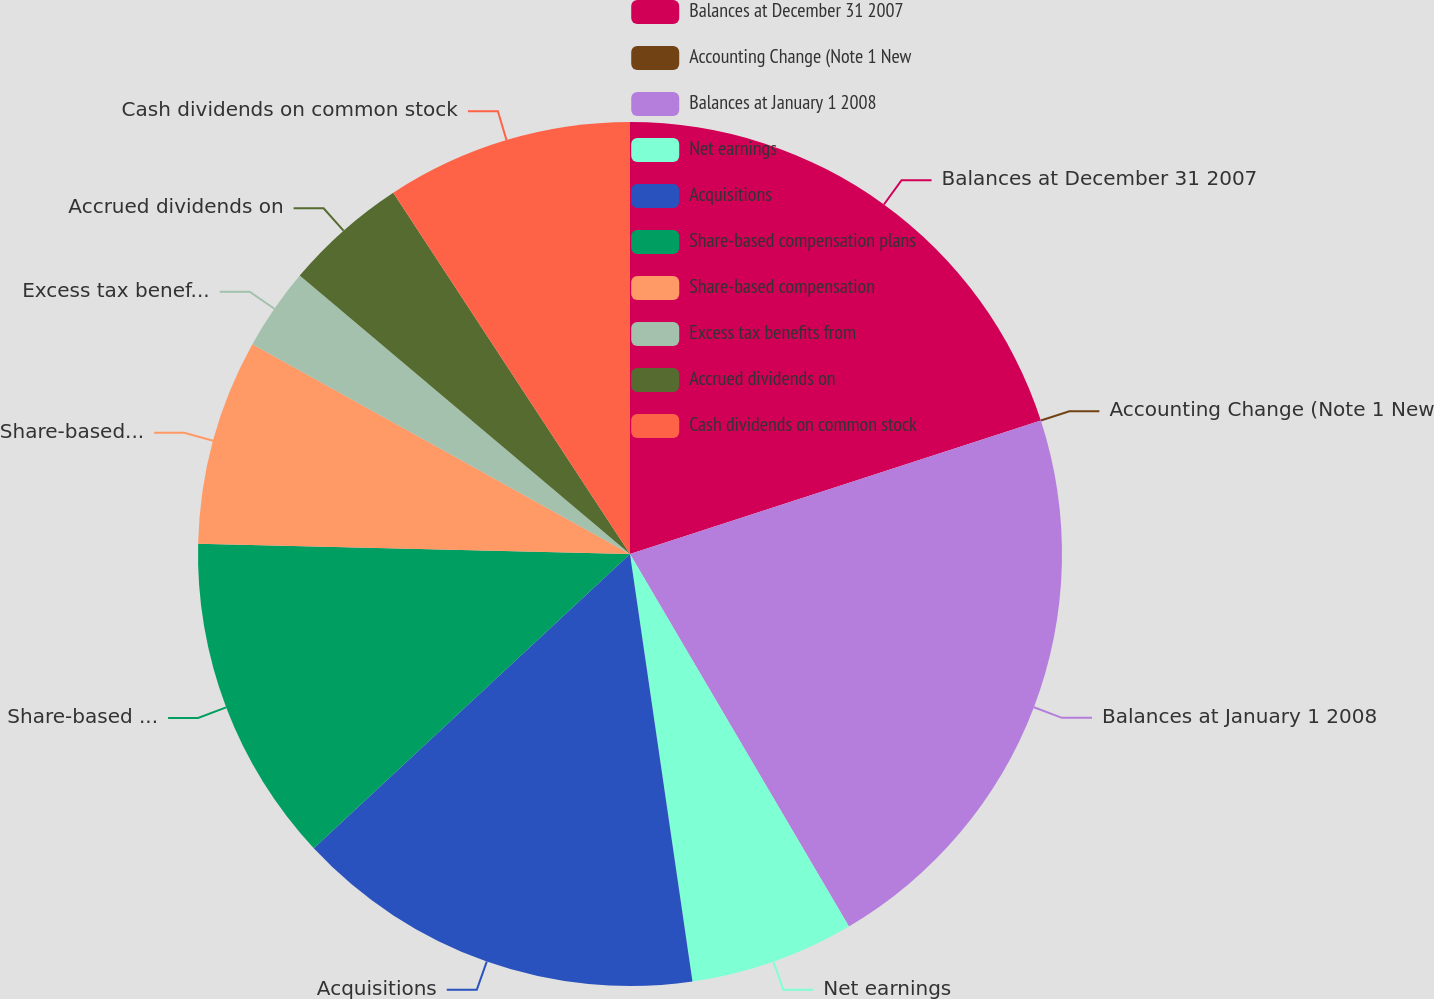Convert chart to OTSL. <chart><loc_0><loc_0><loc_500><loc_500><pie_chart><fcel>Balances at December 31 2007<fcel>Accounting Change (Note 1 New<fcel>Balances at January 1 2008<fcel>Net earnings<fcel>Acquisitions<fcel>Share-based compensation plans<fcel>Share-based compensation<fcel>Excess tax benefits from<fcel>Accrued dividends on<fcel>Cash dividends on common stock<nl><fcel>20.0%<fcel>0.0%<fcel>21.54%<fcel>6.15%<fcel>15.38%<fcel>12.31%<fcel>7.69%<fcel>3.08%<fcel>4.62%<fcel>9.23%<nl></chart> 